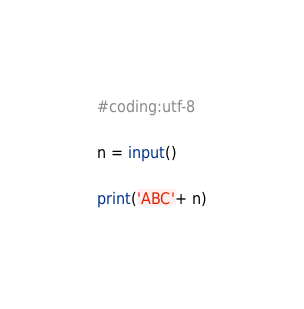<code> <loc_0><loc_0><loc_500><loc_500><_Python_>#coding:utf-8

n = input()

print('ABC'+ n)</code> 